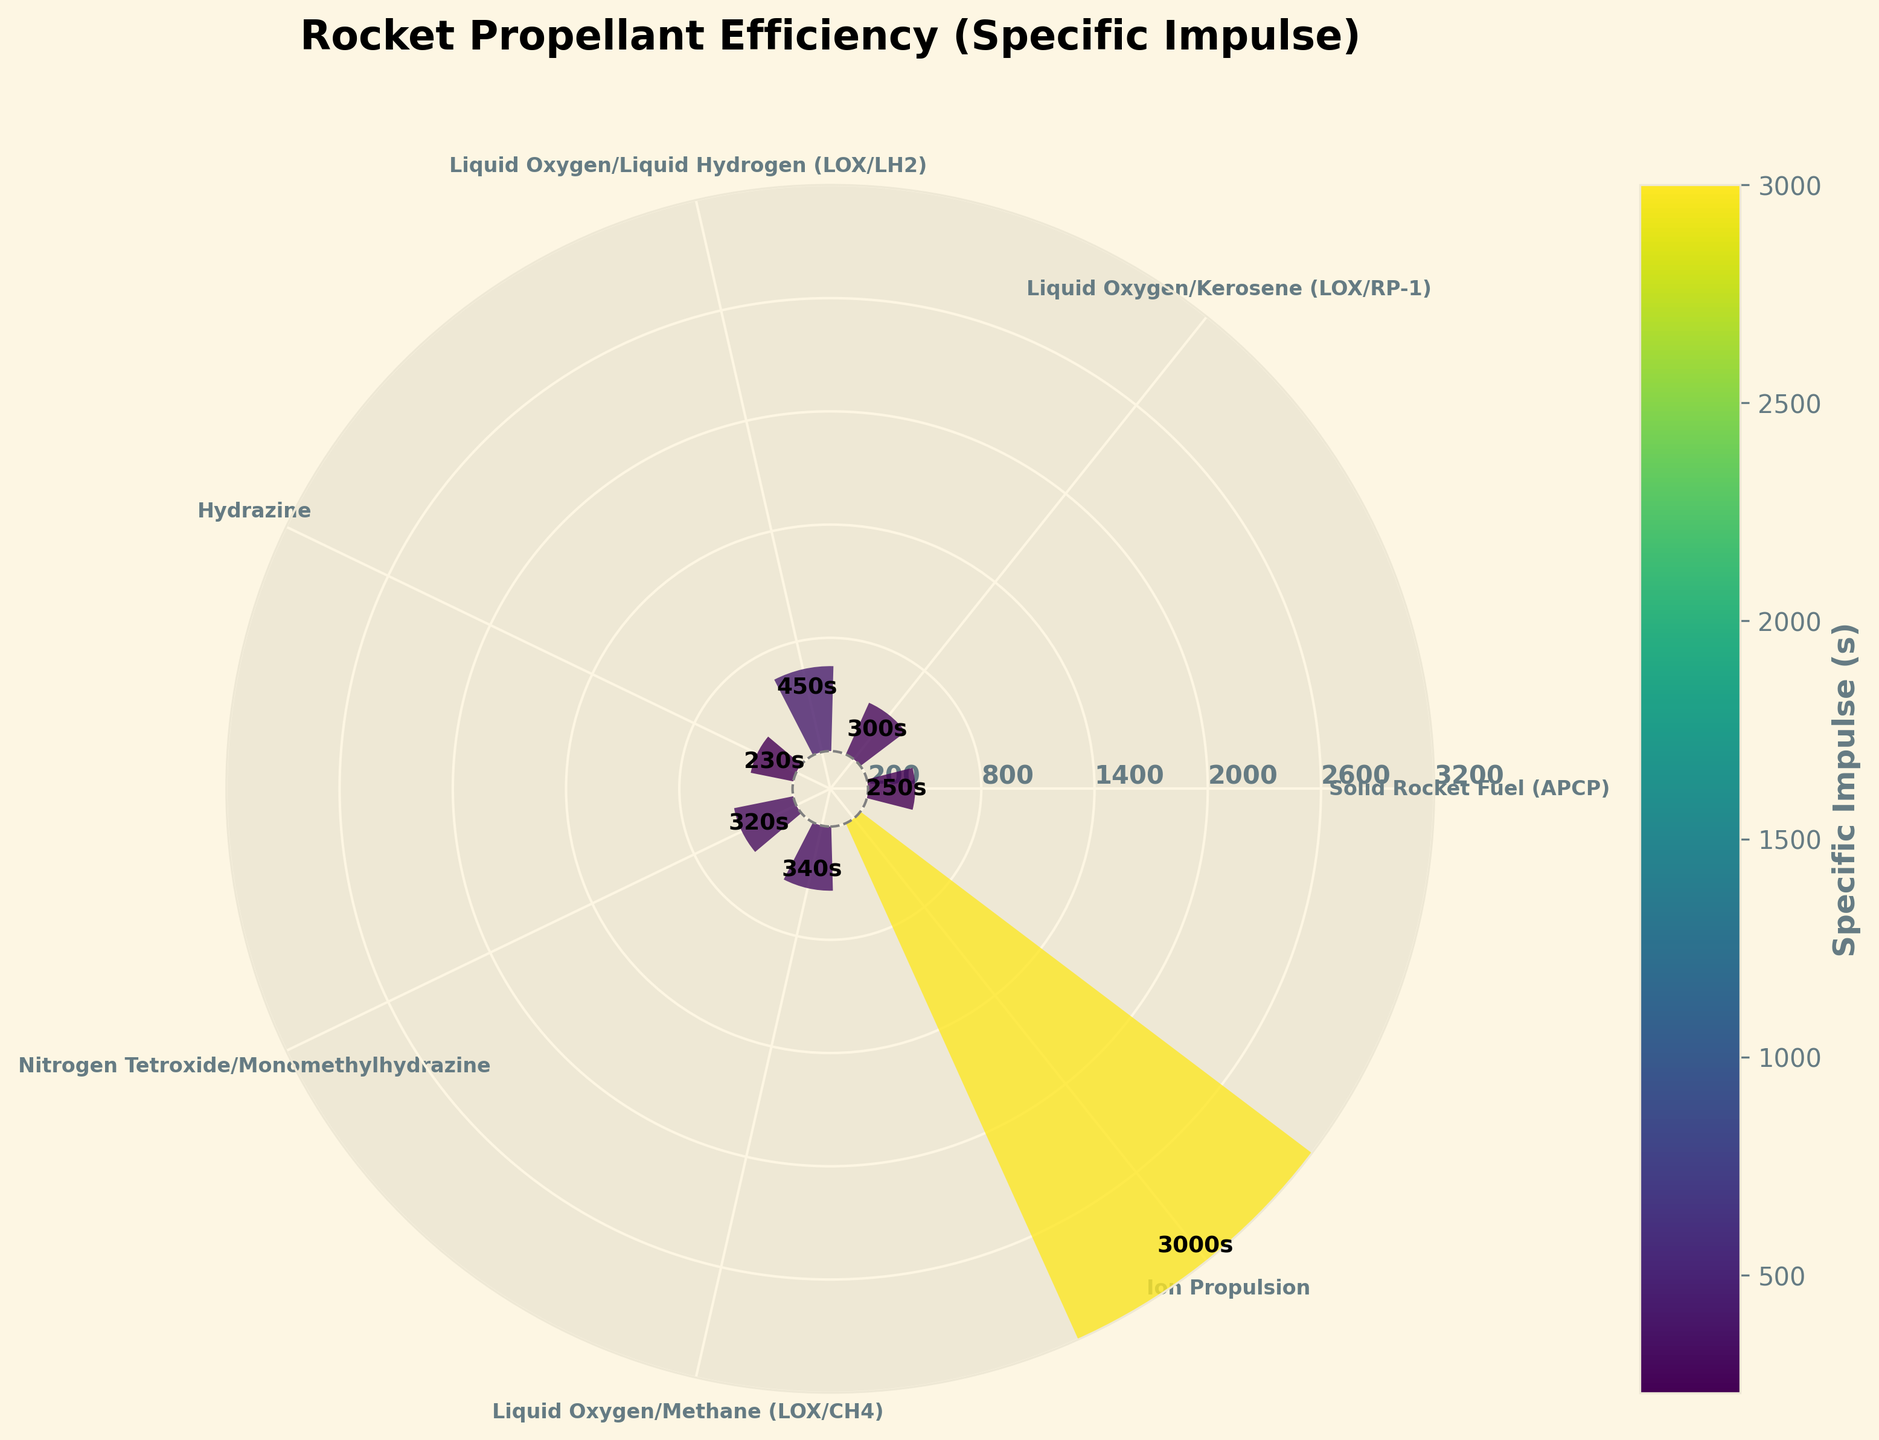What is the title of the gauge chart? The title is usually displayed at the top of the figure. In this gauge chart, the title is "Rocket Propellant Efficiency (Specific Impulse)."
Answer: Rocket Propellant Efficiency (Specific Impulse) How many propellant types are compared in the figure? Count the number of different propellant types listed as labels around the circular gauge chart. There are 7 propellant types in total.
Answer: 7 Which propellant type has the highest specific impulse? Look for the bar that extends the farthest from the center of the chart. The propellant with the highest specific impulse is identified as "Ion Propulsion."
Answer: Ion Propulsion What is the specific impulse of Liquid Oxygen/Liquid Hydrogen (LOX/LH2)? Locate the label "Liquid Oxygen/Liquid Hydrogen (LOX/LH2)" on the chart, and read the value annotated near the end of its corresponding bar. The value is 450 seconds.
Answer: 450 seconds Which propellant type has a specific impulse less than 250s? Identify the bars that are shorter than the 250s mark. The propellants with specific impulses below this threshold are "Solid Rocket Fuel (APCP)" and "Hydrazine."
Answer: Solid Rocket Fuel (APCP) and Hydrazine By how much does the specific impulse of LOX/CH4 exceed that of LOX/RP-1? First, find the specific impulse values of LOX/CH4 and LOX/RP-1 which are 340s and 300s respectively. Then, subtract the specific impulse of LOX/RP-1 from that of LOX/CH4: 340 - 300 = 40.
Answer: 40 seconds What is the range of specific impulse values illustrated in the gauge chart? Identify the minimum and maximum specific impulse values by examining the shortest and longest bars. The range is from 230 seconds (Hydrazine) to 3000 seconds (Ion Propulsion).
Answer: 230 to 3000 seconds What is the average specific impulse of all the propellant types? Add up all the specific impulse values from the seven propellants and then divide by the number of propellants: (250 + 300 + 450 + 230 + 320 + 340 + 3000) / 7 = 6940 / 7 ≈ 991.43 seconds.
Answer: 991.43 seconds Which propellant has a specific impulse closest to 300s? Compare the specific impulse values to 300 and find the nearest value. Both "Liquid Oxygen/Kerosene (LOX/RP-1)" and "Ion Propulsion" have specific impulses exactly equal to 300s.
Answer: Liquid Oxygen/Kerosene (LOX/RP-1) and Ion Propulsion 